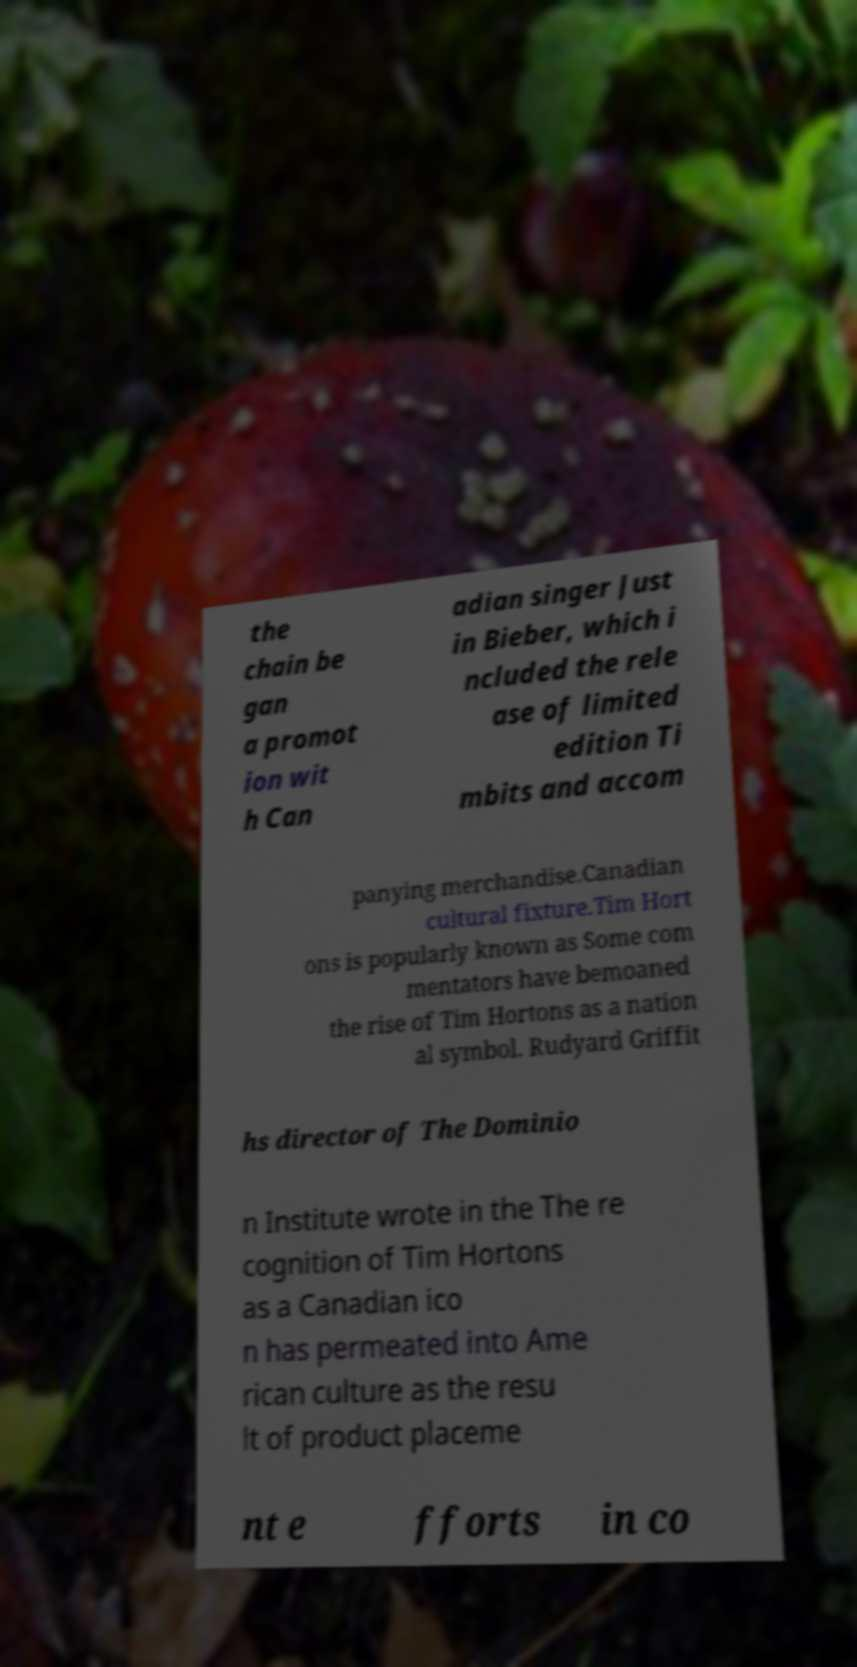Please read and relay the text visible in this image. What does it say? the chain be gan a promot ion wit h Can adian singer Just in Bieber, which i ncluded the rele ase of limited edition Ti mbits and accom panying merchandise.Canadian cultural fixture.Tim Hort ons is popularly known as Some com mentators have bemoaned the rise of Tim Hortons as a nation al symbol. Rudyard Griffit hs director of The Dominio n Institute wrote in the The re cognition of Tim Hortons as a Canadian ico n has permeated into Ame rican culture as the resu lt of product placeme nt e fforts in co 